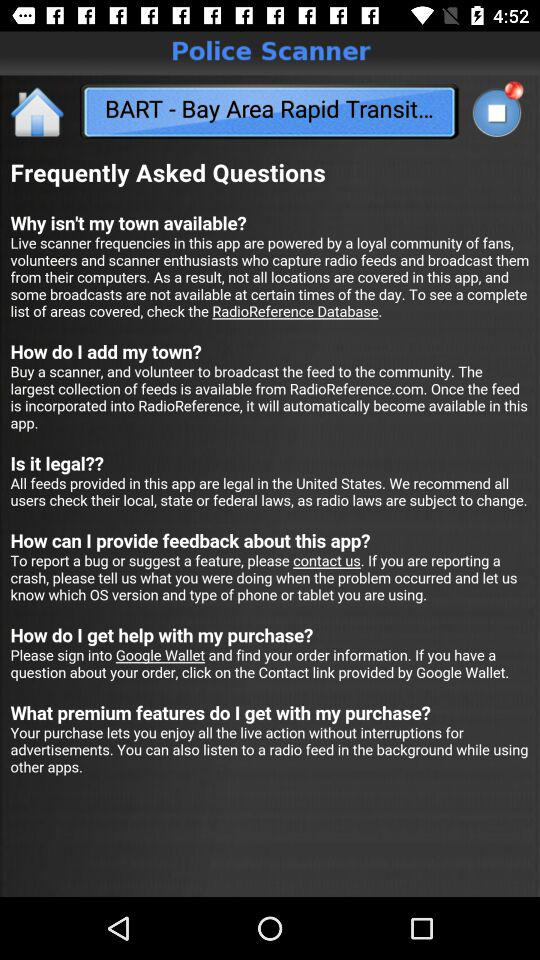How many FAQs are there?
Answer the question using a single word or phrase. 6 